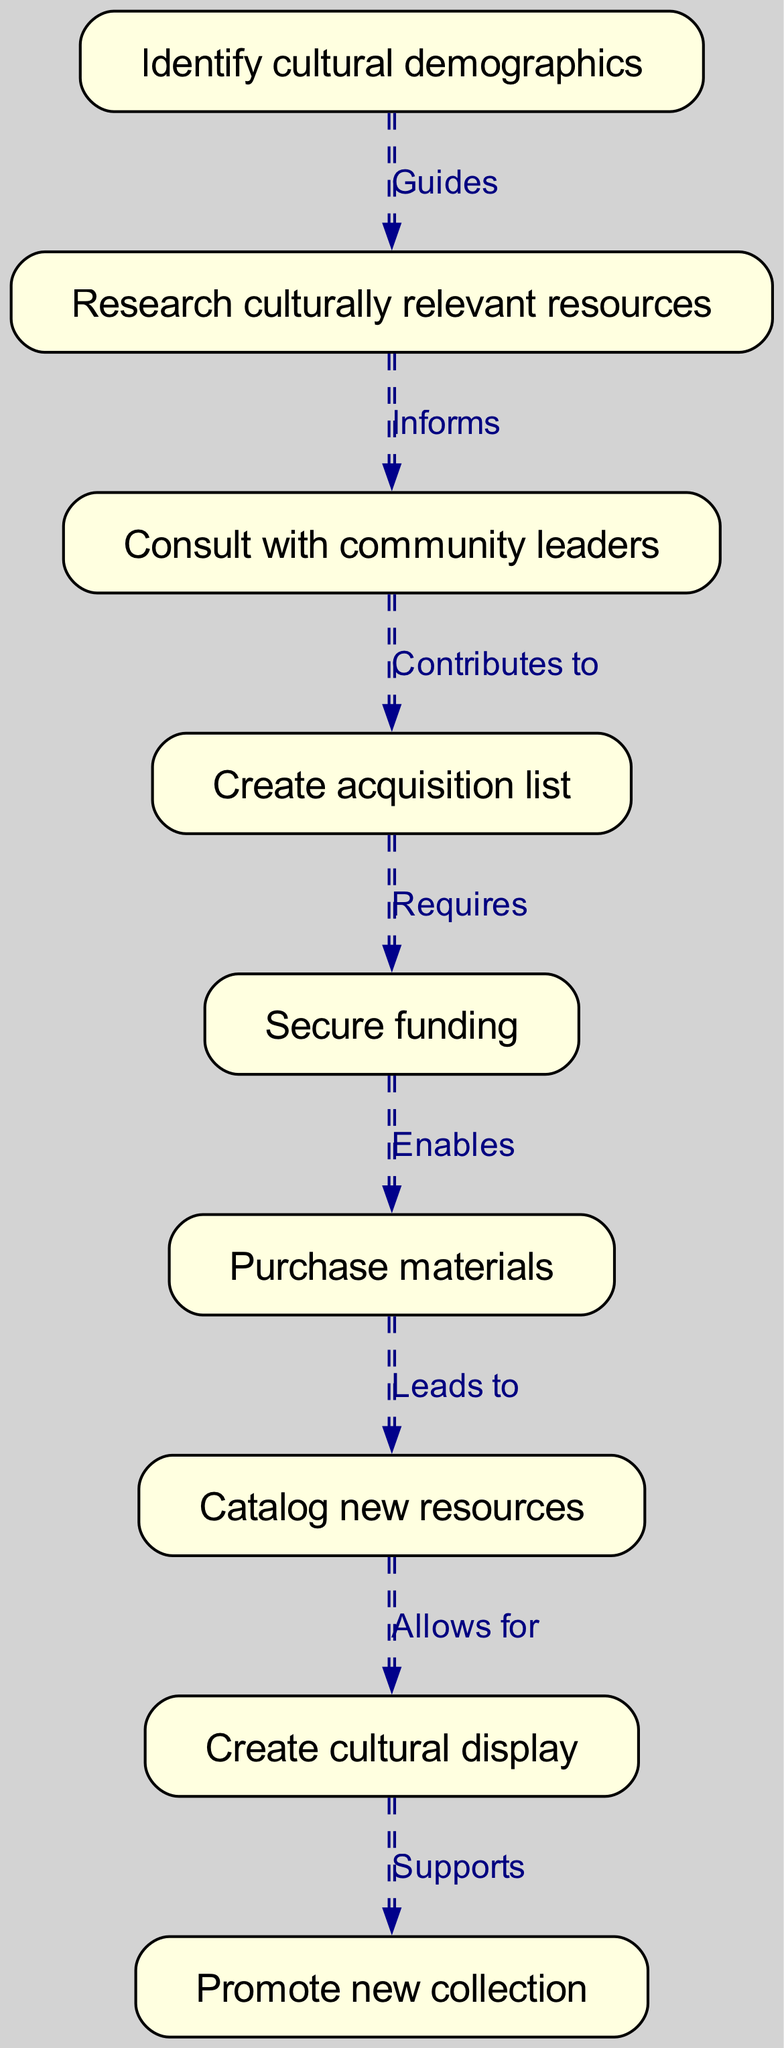What is the first step in the process? The first step is represented by the node labeled "Identify cultural demographics." This is the starting point of the flowchart, leading to the next step.
Answer: Identify cultural demographics How many nodes are there in total? By counting the unique nodes presented in the diagram, we find there are nine distinct steps or nodes that describe the acquisition process.
Answer: Nine What action does "Purchase materials" lead to? According to the diagram, the node labeled "Purchase materials" is linked to the next step "Catalog new resources," indicating that the purchase of new materials directly leads to the cataloging process.
Answer: Catalog new resources Which step requires securing funding? The step that requires securing funding is indicated in the flow diagram as "Create acquisition list," which is connected to the "Secure funding" node, showing that funding is necessary after creating the acquisition list.
Answer: Create acquisition list What supports the promotion of the new collection? The action that supports the promotion of the new collection is represented by the prior step, which is "Create cultural display." This indicates that the cultural display helps in promoting the newly acquired resources in the library.
Answer: Create cultural display Which nodes inform each other in the process? The two steps that inform each other are "Research culturally relevant resources" and "Consult with community leaders." The edge between these nodes shows that the research is based on information from community leaders' consultations.
Answer: Research culturally relevant resources and Consult with community leaders What is the final outcome of this diagram? The final outcome of the diagram is illustrated in the node labeled "Promote new collection," which signifies that the entire flow culminates in promoting newly acquired culturally diverse resources.
Answer: Promote new collection 